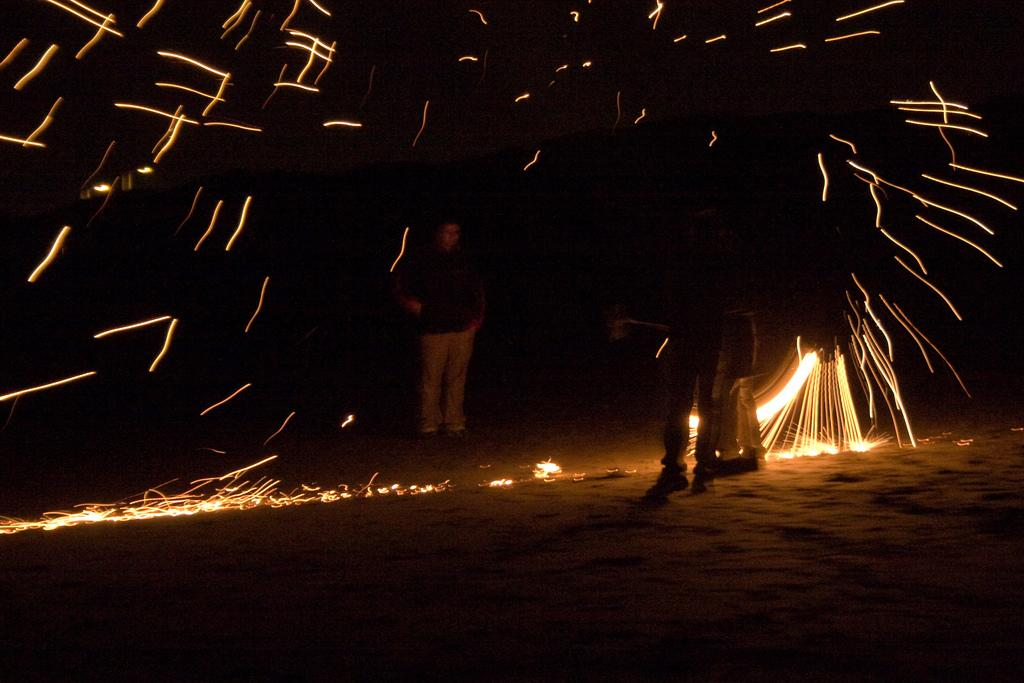What is present in the image? There are people in the image. What can be observed about the background of the image? The background of the image is dark. What type of advertisement can be seen in the image? There is no advertisement present in the image. Is there a stream or body of water visible in the image? There is no stream or body of water visible in the image. Is there any steam coming from any objects or people in the image? There is no steam present in the image. 